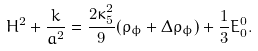Convert formula to latex. <formula><loc_0><loc_0><loc_500><loc_500>H ^ { 2 } + \frac { k } { a ^ { 2 } } = \frac { 2 \kappa _ { 5 } ^ { 2 } } { 9 } ( \rho _ { \phi } + \Delta \rho _ { \phi } ) + \frac { 1 } { 3 } E _ { 0 } ^ { 0 } .</formula> 